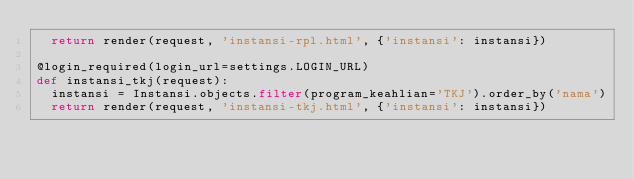<code> <loc_0><loc_0><loc_500><loc_500><_Python_>  return render(request, 'instansi-rpl.html', {'instansi': instansi})

@login_required(login_url=settings.LOGIN_URL)
def instansi_tkj(request):
  instansi = Instansi.objects.filter(program_keahlian='TKJ').order_by('nama')
  return render(request, 'instansi-tkj.html', {'instansi': instansi})</code> 